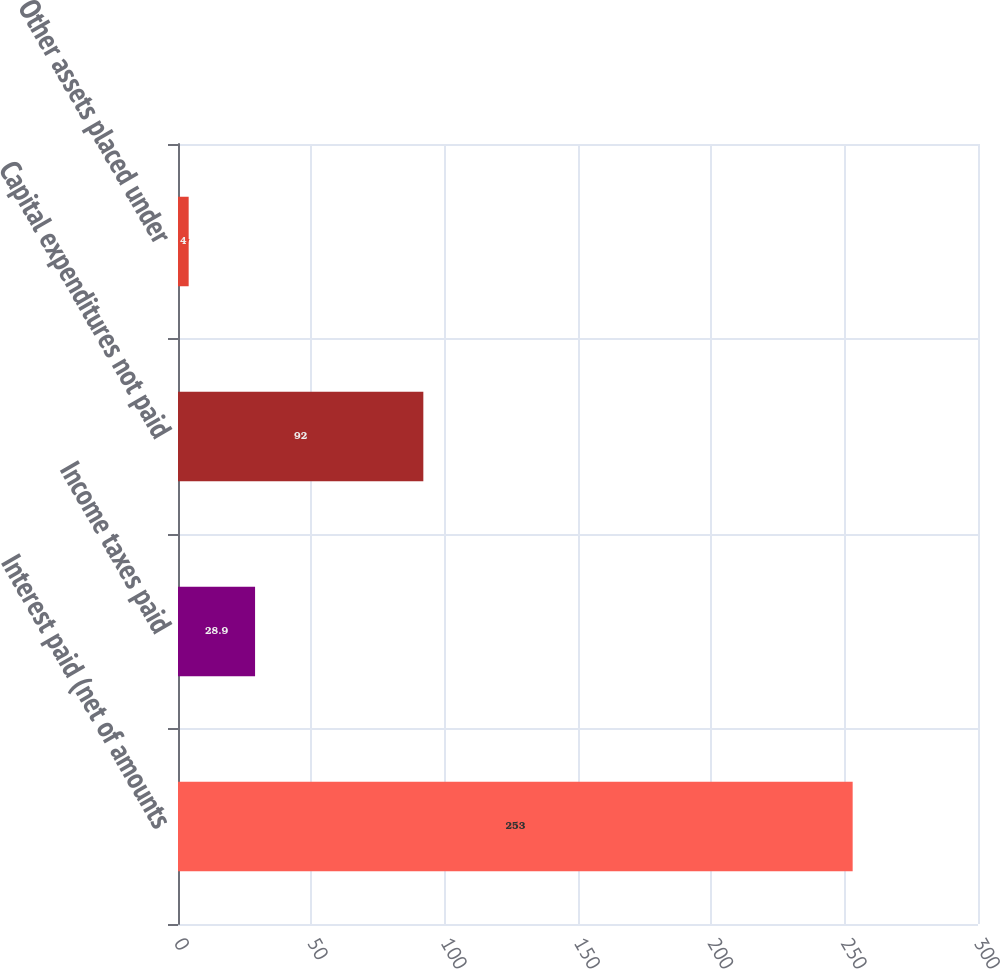Convert chart to OTSL. <chart><loc_0><loc_0><loc_500><loc_500><bar_chart><fcel>Interest paid (net of amounts<fcel>Income taxes paid<fcel>Capital expenditures not paid<fcel>Other assets placed under<nl><fcel>253<fcel>28.9<fcel>92<fcel>4<nl></chart> 